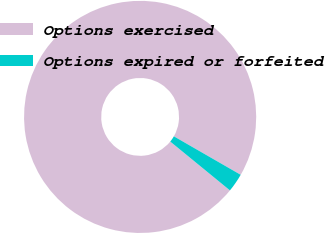<chart> <loc_0><loc_0><loc_500><loc_500><pie_chart><fcel>Options exercised<fcel>Options expired or forfeited<nl><fcel>97.4%<fcel>2.6%<nl></chart> 